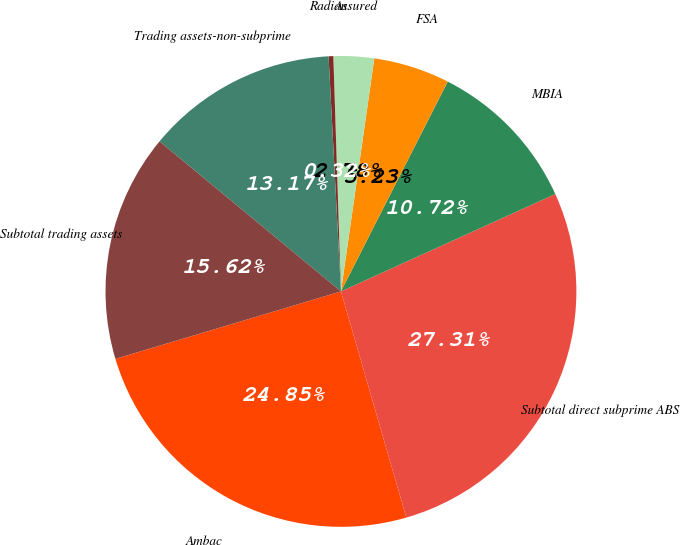Convert chart to OTSL. <chart><loc_0><loc_0><loc_500><loc_500><pie_chart><fcel>Ambac<fcel>Subtotal direct subprime ABS<fcel>MBIA<fcel>FSA<fcel>Assured<fcel>Radian<fcel>Trading assets-non-subprime<fcel>Subtotal trading assets<nl><fcel>24.85%<fcel>27.31%<fcel>10.72%<fcel>5.23%<fcel>2.78%<fcel>0.32%<fcel>13.17%<fcel>15.62%<nl></chart> 